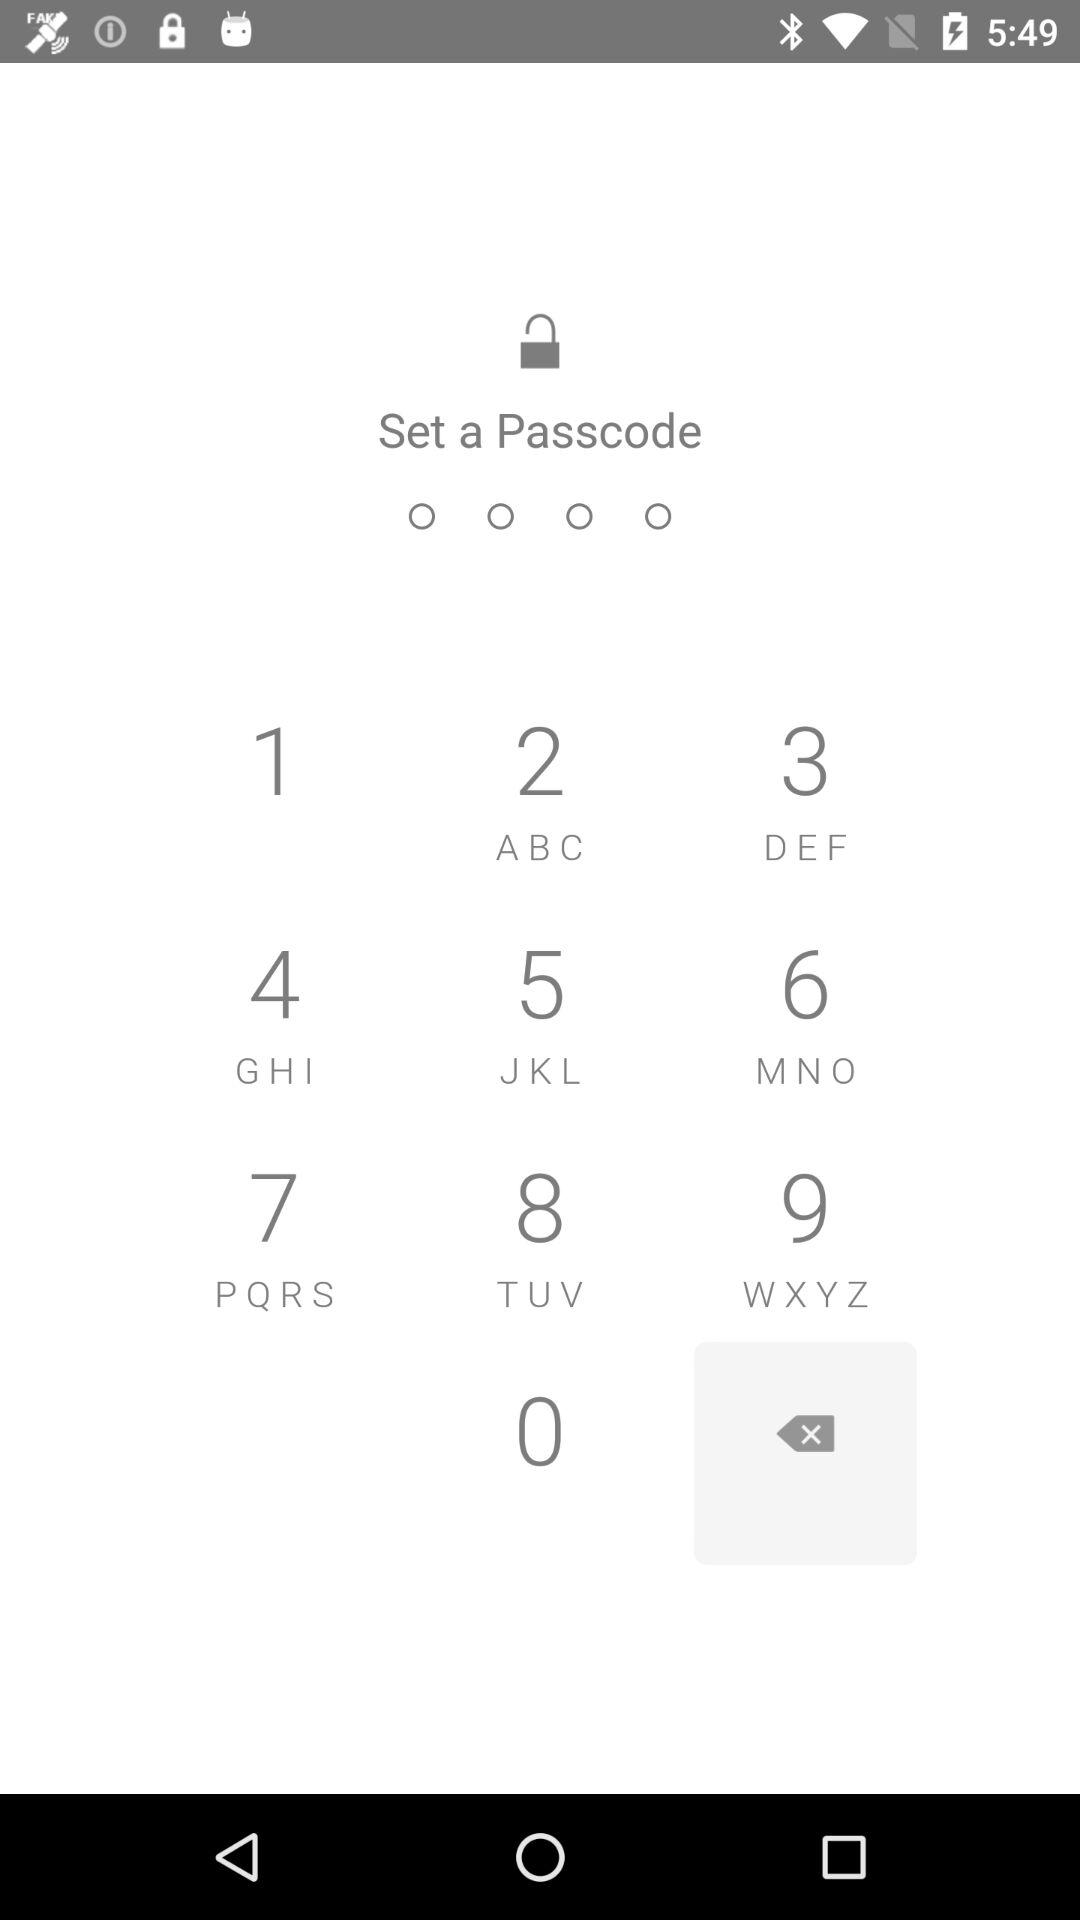How many rows are in the keyboard?
Answer the question using a single word or phrase. 4 